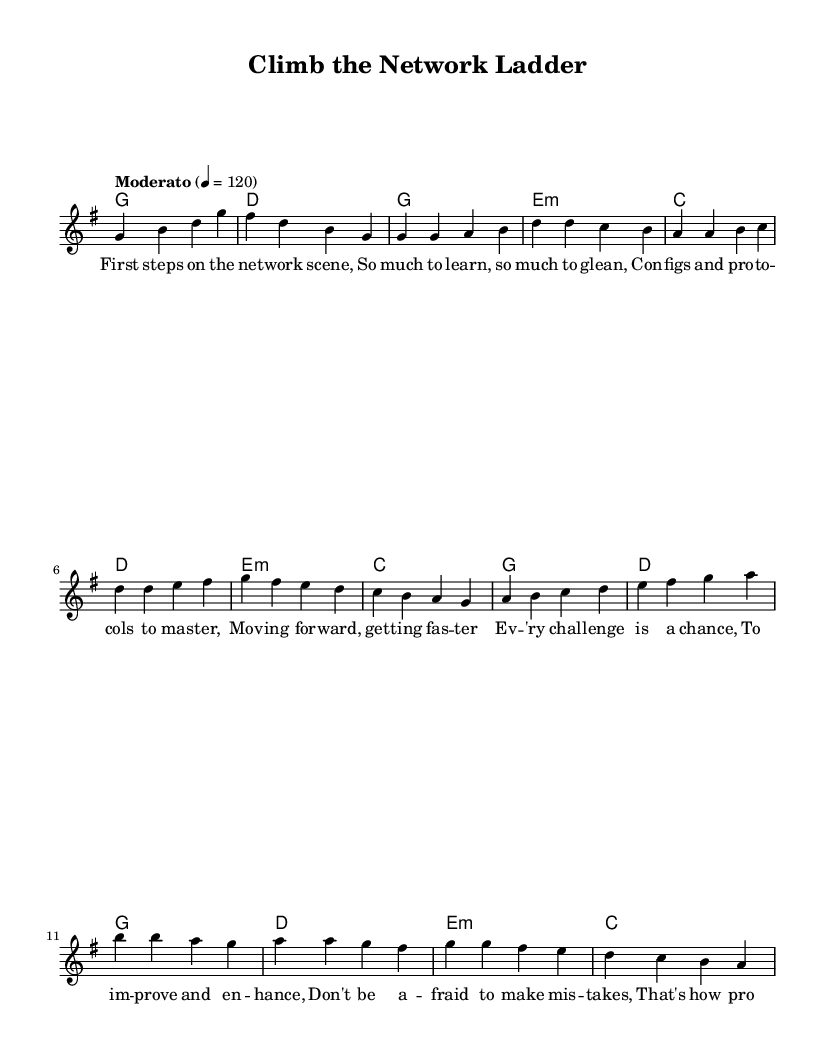What is the key signature of this music? The key signature is G major, which has one sharp (F#). This can be deduced from the global section where the key is indicated as \key g \major.
Answer: G major What is the time signature of this music? The time signature is 4/4, which means there are four beats in a measure and the quarter note gets one beat. This is explicitly stated in the global section as \time 4/4.
Answer: 4/4 What is the tempo marking for this piece? The tempo marking is Moderato, which suggests a moderate speed. This is indicated in the tempo section with the instruction "Moderato" followed by a metronome marking of 4 = 120.
Answer: Moderato How many measures are in the chorus section? The chorus section consists of four measures. This can be determined by counting the distinct segments in the chorus lyrics and the corresponding melody notes.
Answer: 4 What phrase is repeated in the chorus? The phrase "you're on your way" is repeated in the chorus. This can be identified by looking at the lyrics of the chorus section, noting that it appears at both the end of the first and last lines of the chorus.
Answer: you're on your way Which musical form is primarily used in this piece? The piece primarily uses a verse-chorus form. This is discerned by analyzing the structure where the verses are followed by a pre-chorus and then the chorus, which repeats after each cycle.
Answer: verse-chorus What is the last chord of the chorus? The last chord of the chorus is C major. This can be confirmed by looking at the harmonies for the chorus where the last chord listed is identified.
Answer: C major 